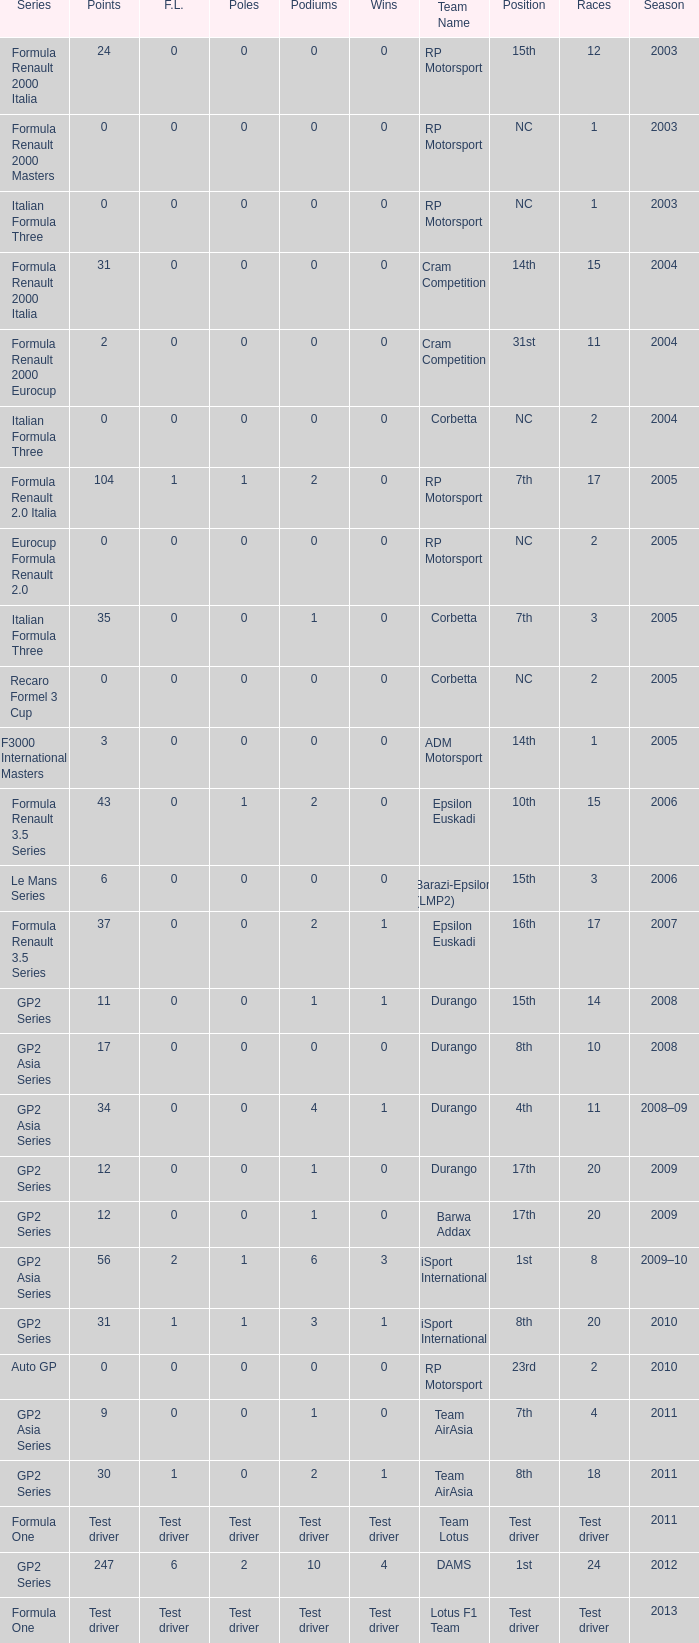What is the number of podiums with 0 wins, 0 F.L. and 35 points? 1.0. 